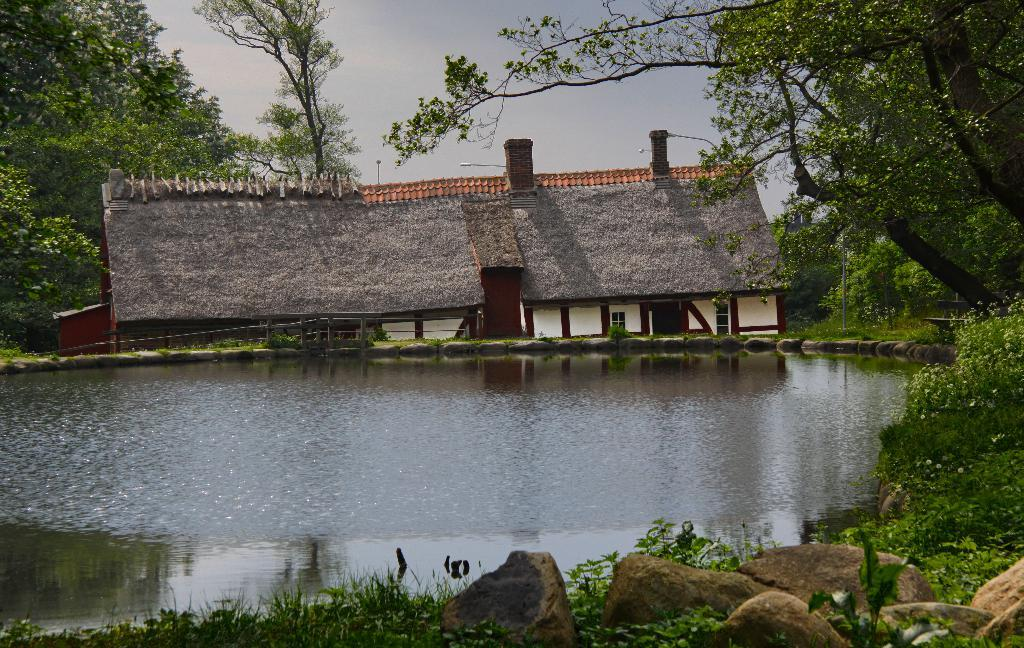What is the primary element visible in the image? There is water in the image. What type of structures can be seen in the image? There are houses in the image. What natural features are present in the image? There are rocks, plants, and trees in the image. What is visible at the top of the image? The sky is visible at the top of the image. How many fingers can be seen pointing at the houses in the image? There are no fingers visible in the image. Are the sisters playing near the water in the image? There is no mention of sisters in the image, and therefore no such activity can be observed. 